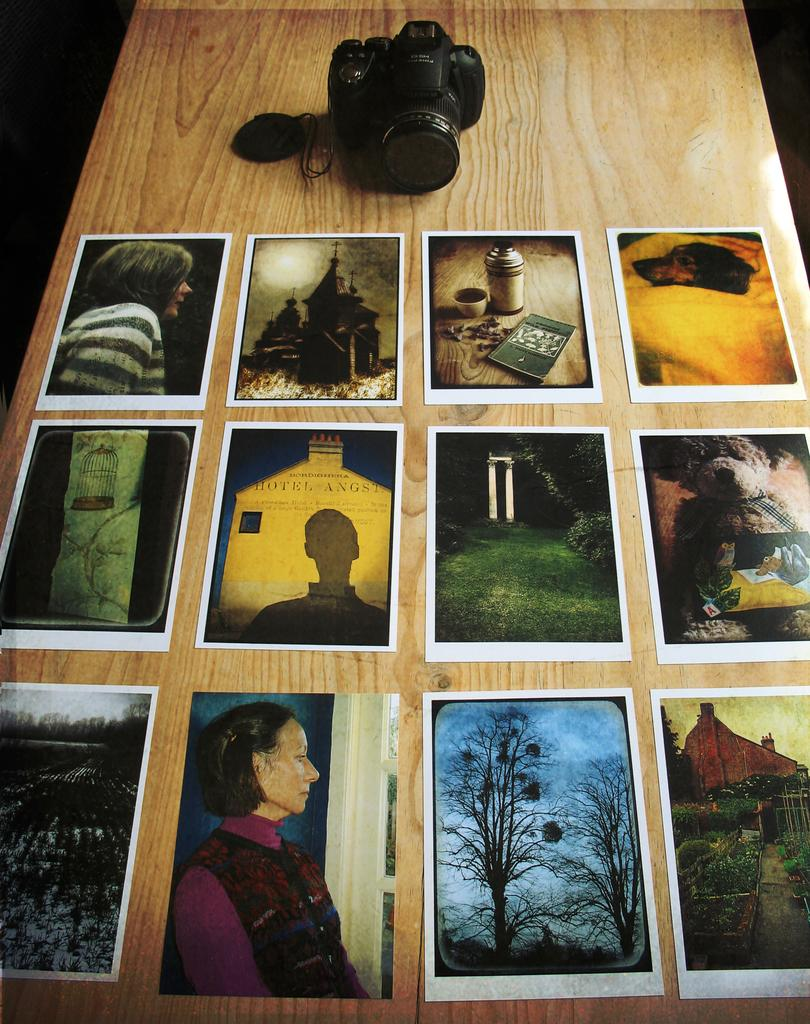What is the main object in the image? There is a camera in the image. What is placed in front of the camera? There are many photographs in front of the camera. What type of surface is the camera and photographs resting on? The wooden table is present in the image. What type of plants can be seen growing on the mountain in the image? There is no mountain or plants present in the image; it features a camera and photographs on a wooden table. 